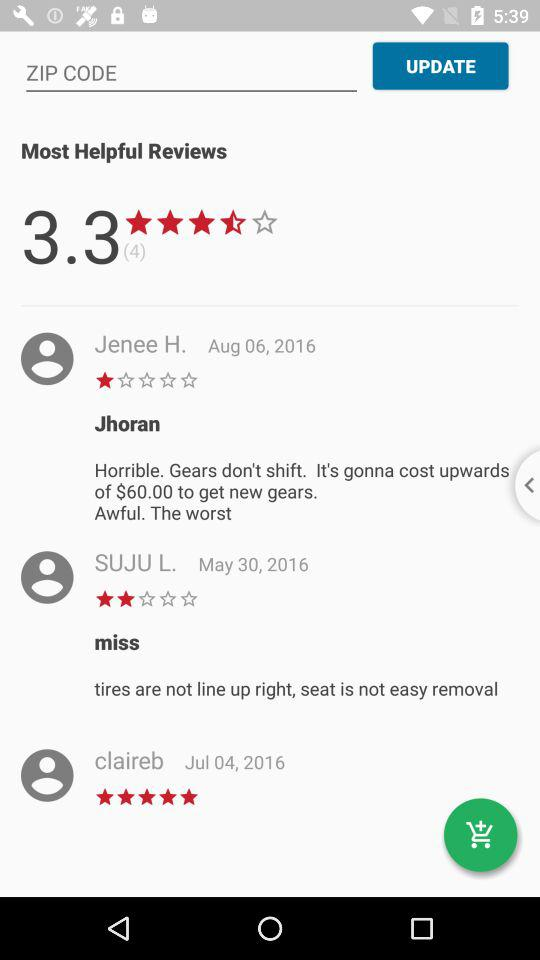When did Jenee H. give the review? Jenee H. gave the review on August 6, 2016. 